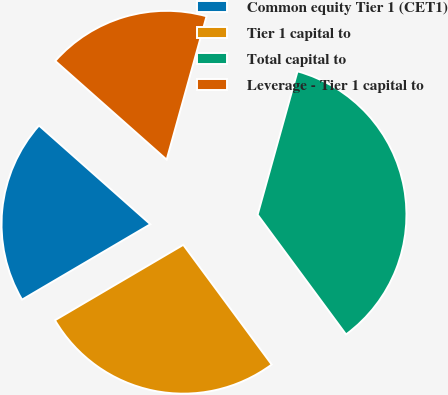<chart> <loc_0><loc_0><loc_500><loc_500><pie_chart><fcel>● Common equity Tier 1 (CET1)<fcel>● Tier 1 capital to<fcel>● Total capital to<fcel>● Leverage - Tier 1 capital to<nl><fcel>20.0%<fcel>26.67%<fcel>35.56%<fcel>17.78%<nl></chart> 